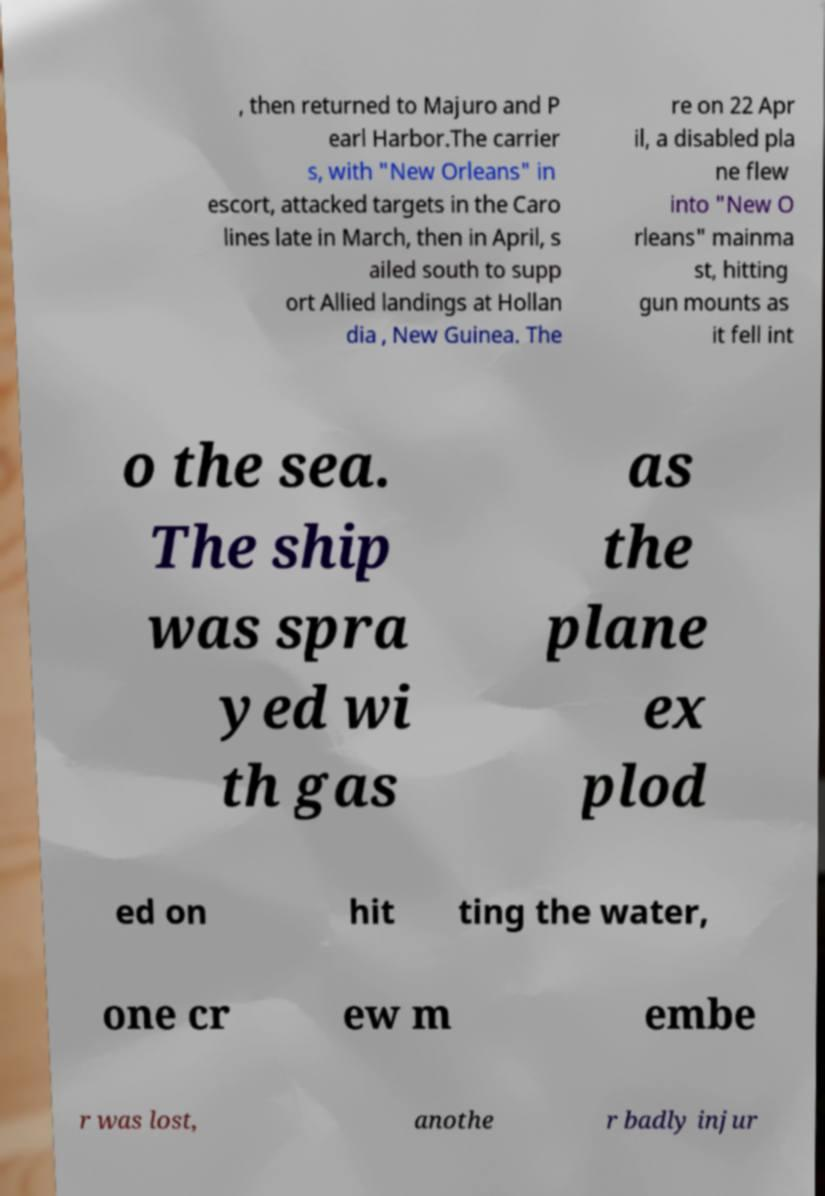Can you read and provide the text displayed in the image?This photo seems to have some interesting text. Can you extract and type it out for me? , then returned to Majuro and P earl Harbor.The carrier s, with "New Orleans" in escort, attacked targets in the Caro lines late in March, then in April, s ailed south to supp ort Allied landings at Hollan dia , New Guinea. The re on 22 Apr il, a disabled pla ne flew into "New O rleans" mainma st, hitting gun mounts as it fell int o the sea. The ship was spra yed wi th gas as the plane ex plod ed on hit ting the water, one cr ew m embe r was lost, anothe r badly injur 